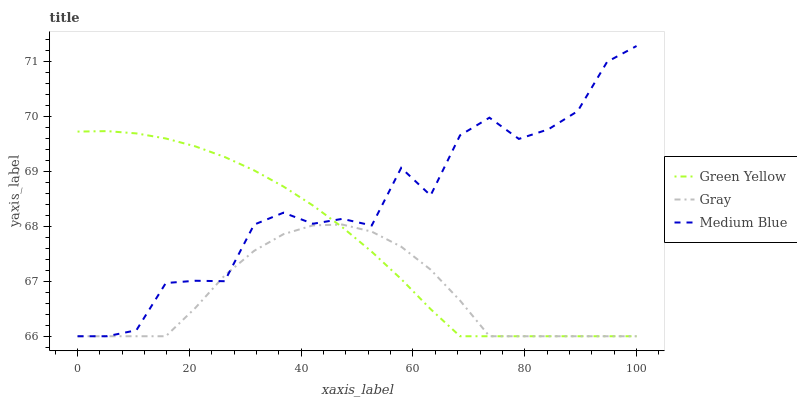Does Gray have the minimum area under the curve?
Answer yes or no. Yes. Does Medium Blue have the maximum area under the curve?
Answer yes or no. Yes. Does Green Yellow have the minimum area under the curve?
Answer yes or no. No. Does Green Yellow have the maximum area under the curve?
Answer yes or no. No. Is Green Yellow the smoothest?
Answer yes or no. Yes. Is Medium Blue the roughest?
Answer yes or no. Yes. Is Medium Blue the smoothest?
Answer yes or no. No. Is Green Yellow the roughest?
Answer yes or no. No. Does Gray have the lowest value?
Answer yes or no. Yes. Does Medium Blue have the highest value?
Answer yes or no. Yes. Does Green Yellow have the highest value?
Answer yes or no. No. Does Gray intersect Medium Blue?
Answer yes or no. Yes. Is Gray less than Medium Blue?
Answer yes or no. No. Is Gray greater than Medium Blue?
Answer yes or no. No. 